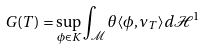<formula> <loc_0><loc_0><loc_500><loc_500>G ( T ) = \sup _ { \phi \in K } \int _ { \mathcal { M } } \theta \langle \phi , \nu _ { T } \rangle d \mathcal { H } ^ { 1 }</formula> 